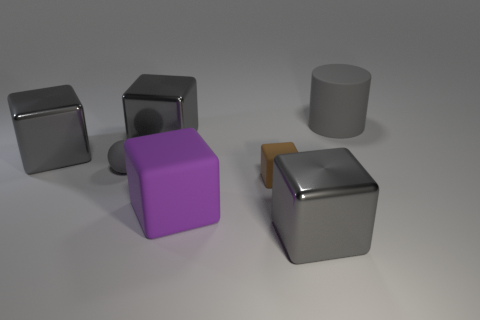Is the purple matte object the same shape as the brown matte thing?
Your answer should be very brief. Yes. Are there fewer small gray balls on the left side of the large purple thing than big purple metallic objects?
Give a very brief answer. No. There is a rubber thing behind the gray matte object that is in front of the gray rubber thing that is behind the small ball; what color is it?
Provide a succinct answer. Gray. What number of matte things are small gray objects or small cubes?
Give a very brief answer. 2. Is the size of the brown object the same as the purple object?
Keep it short and to the point. No. Is the number of purple matte cubes that are in front of the big purple rubber object less than the number of big metal objects that are on the left side of the small gray rubber thing?
Offer a very short reply. Yes. How big is the ball?
Your answer should be very brief. Small. What number of large things are either gray metallic things or gray rubber things?
Provide a succinct answer. 4. There is a gray cylinder; is it the same size as the gray matte object that is to the left of the rubber cylinder?
Provide a short and direct response. No. Are there any other things that are the same shape as the small gray rubber object?
Offer a terse response. No. 